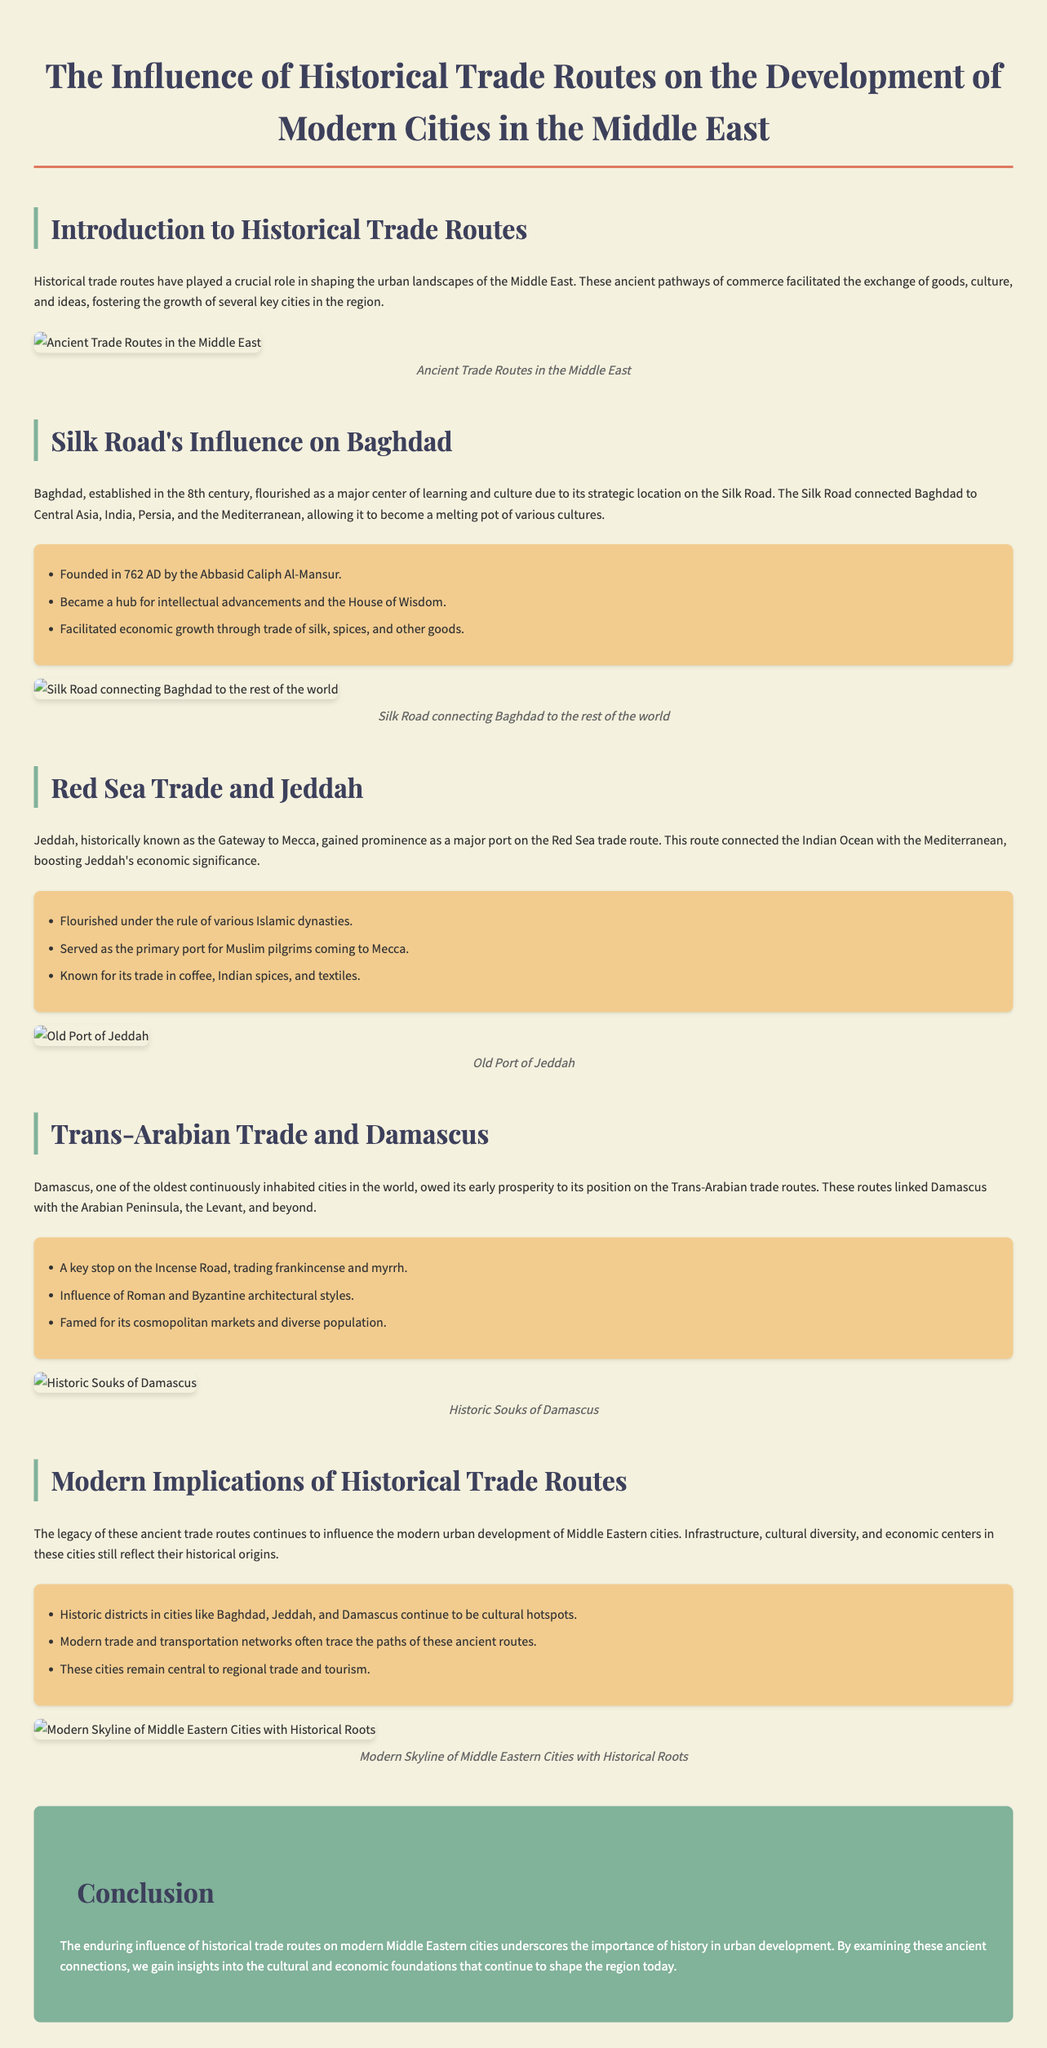What city was founded in 762 AD? The document states that Baghdad was founded in 762 AD by the Abbasid Caliph Al-Mansur.
Answer: Baghdad What was Jeddah's historical significance? Jeddah is described as the Gateway to Mecca and gained prominence as a major port on the Red Sea trade route.
Answer: Gateway to Mecca Which road did Damascus prosper along? The document highlights that Damascus prospered due to its position on the Trans-Arabian trade routes.
Answer: Trans-Arabian trade routes What was Baghdad known for in the context of the Silk Road? Baghdad became a hub for intellectual advancements and housed the House of Wisdom due to its strategic location on the Silk Road.
Answer: House of Wisdom What trade goods were commonly associated with Jeddah? The document mentions that Jeddah was known for its trade in coffee, Indian spices, and textiles.
Answer: Coffee, Indian spices, textiles How did historical trade routes affect cultural diversity in modern cities? The infographic notes that historic districts in cities like Baghdad, Jeddah, and Damascus continue to be cultural hotspots.
Answer: Cultural hotspots What role did Damascus play on the Incense Road? The document states that Damascus was a key stop on the Incense Road, trading frankincense and myrrh.
Answer: Key stop on the Incense Road In what way do modern trade and transportation networks relate to historical trade routes? The document indicates that modern trade and transportation networks often trace the paths of these ancient routes.
Answer: Trace paths of ancient routes What is the main conclusion about historical trade routes' impact on urban development? The conclusion emphasizes the enduring influence of historical trade routes on modern Middle Eastern cities.
Answer: Enduring influence 